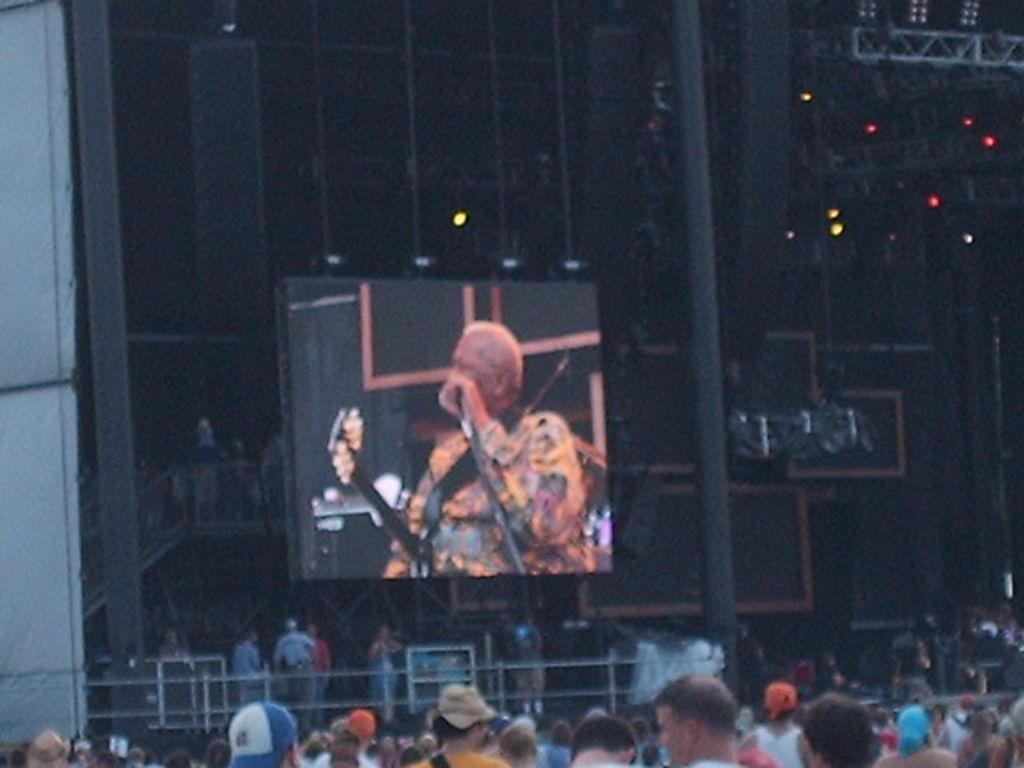How many people are in the image? There are people in the image, but the exact number is not specified. What type of structure is visible in the image? There is a building in the image. What objects are present in the image that might be used for support or guidance? There are poles in the image. What objects in the image might provide illumination? There are lights in the image. What type of architectural feature can be seen in the image? There is a grille in the image. What type of sign or display is present in the image? There is a board in the image. What is depicted on the board in the image? There is a person's image on the board. What is the rate of finger growth in the image? There is no mention of fingers or their growth rate in the image. 